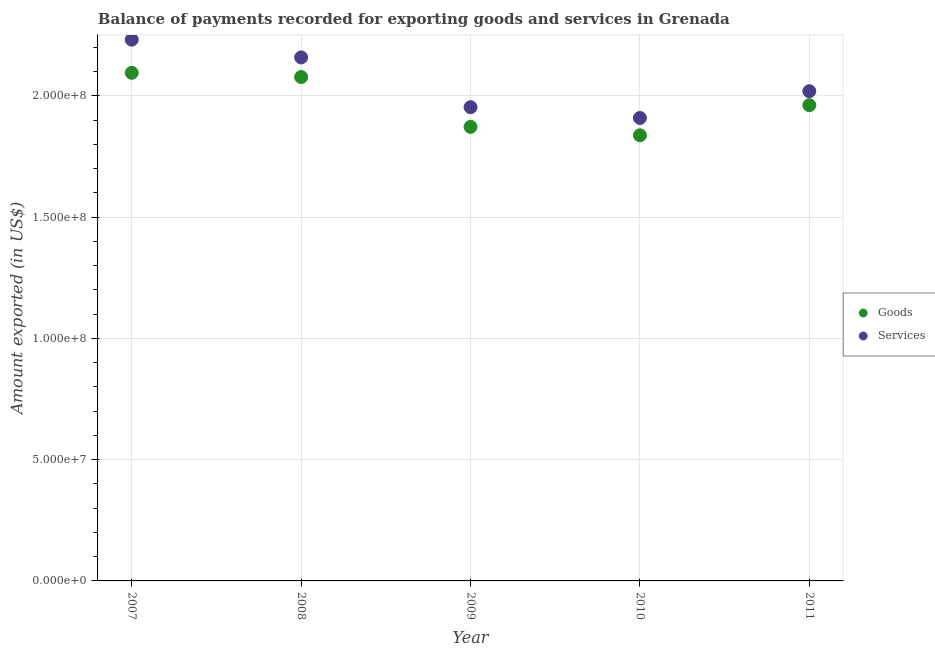What is the amount of goods exported in 2010?
Your response must be concise. 1.84e+08. Across all years, what is the maximum amount of services exported?
Make the answer very short. 2.23e+08. Across all years, what is the minimum amount of goods exported?
Your answer should be compact. 1.84e+08. In which year was the amount of goods exported maximum?
Your answer should be compact. 2007. What is the total amount of services exported in the graph?
Your response must be concise. 1.03e+09. What is the difference between the amount of goods exported in 2007 and that in 2010?
Your answer should be compact. 2.58e+07. What is the difference between the amount of goods exported in 2011 and the amount of services exported in 2008?
Keep it short and to the point. -1.97e+07. What is the average amount of goods exported per year?
Your answer should be very brief. 1.97e+08. In the year 2007, what is the difference between the amount of goods exported and amount of services exported?
Your answer should be very brief. -1.37e+07. What is the ratio of the amount of goods exported in 2008 to that in 2009?
Keep it short and to the point. 1.11. Is the difference between the amount of goods exported in 2009 and 2011 greater than the difference between the amount of services exported in 2009 and 2011?
Give a very brief answer. No. What is the difference between the highest and the second highest amount of goods exported?
Keep it short and to the point. 1.75e+06. What is the difference between the highest and the lowest amount of services exported?
Your response must be concise. 3.23e+07. In how many years, is the amount of goods exported greater than the average amount of goods exported taken over all years?
Offer a very short reply. 2. Does the amount of services exported monotonically increase over the years?
Ensure brevity in your answer.  No. Is the amount of goods exported strictly greater than the amount of services exported over the years?
Offer a very short reply. No. How many dotlines are there?
Your response must be concise. 2. Where does the legend appear in the graph?
Your answer should be very brief. Center right. How are the legend labels stacked?
Give a very brief answer. Vertical. What is the title of the graph?
Ensure brevity in your answer.  Balance of payments recorded for exporting goods and services in Grenada. What is the label or title of the Y-axis?
Provide a succinct answer. Amount exported (in US$). What is the Amount exported (in US$) of Goods in 2007?
Provide a short and direct response. 2.10e+08. What is the Amount exported (in US$) of Services in 2007?
Ensure brevity in your answer.  2.23e+08. What is the Amount exported (in US$) in Goods in 2008?
Give a very brief answer. 2.08e+08. What is the Amount exported (in US$) in Services in 2008?
Offer a very short reply. 2.16e+08. What is the Amount exported (in US$) of Goods in 2009?
Make the answer very short. 1.87e+08. What is the Amount exported (in US$) in Services in 2009?
Offer a very short reply. 1.95e+08. What is the Amount exported (in US$) of Goods in 2010?
Your response must be concise. 1.84e+08. What is the Amount exported (in US$) of Services in 2010?
Your response must be concise. 1.91e+08. What is the Amount exported (in US$) of Goods in 2011?
Provide a short and direct response. 1.96e+08. What is the Amount exported (in US$) of Services in 2011?
Offer a very short reply. 2.02e+08. Across all years, what is the maximum Amount exported (in US$) of Goods?
Offer a terse response. 2.10e+08. Across all years, what is the maximum Amount exported (in US$) in Services?
Ensure brevity in your answer.  2.23e+08. Across all years, what is the minimum Amount exported (in US$) of Goods?
Your answer should be very brief. 1.84e+08. Across all years, what is the minimum Amount exported (in US$) of Services?
Your answer should be very brief. 1.91e+08. What is the total Amount exported (in US$) in Goods in the graph?
Keep it short and to the point. 9.85e+08. What is the total Amount exported (in US$) in Services in the graph?
Offer a very short reply. 1.03e+09. What is the difference between the Amount exported (in US$) in Goods in 2007 and that in 2008?
Provide a short and direct response. 1.75e+06. What is the difference between the Amount exported (in US$) in Services in 2007 and that in 2008?
Offer a terse response. 7.32e+06. What is the difference between the Amount exported (in US$) in Goods in 2007 and that in 2009?
Make the answer very short. 2.23e+07. What is the difference between the Amount exported (in US$) of Services in 2007 and that in 2009?
Your answer should be very brief. 2.78e+07. What is the difference between the Amount exported (in US$) in Goods in 2007 and that in 2010?
Make the answer very short. 2.58e+07. What is the difference between the Amount exported (in US$) in Services in 2007 and that in 2010?
Give a very brief answer. 3.23e+07. What is the difference between the Amount exported (in US$) of Goods in 2007 and that in 2011?
Your answer should be compact. 1.34e+07. What is the difference between the Amount exported (in US$) in Services in 2007 and that in 2011?
Your response must be concise. 2.13e+07. What is the difference between the Amount exported (in US$) in Goods in 2008 and that in 2009?
Your answer should be very brief. 2.06e+07. What is the difference between the Amount exported (in US$) in Services in 2008 and that in 2009?
Your answer should be compact. 2.05e+07. What is the difference between the Amount exported (in US$) in Goods in 2008 and that in 2010?
Offer a very short reply. 2.40e+07. What is the difference between the Amount exported (in US$) in Services in 2008 and that in 2010?
Make the answer very short. 2.50e+07. What is the difference between the Amount exported (in US$) in Goods in 2008 and that in 2011?
Your answer should be compact. 1.16e+07. What is the difference between the Amount exported (in US$) of Services in 2008 and that in 2011?
Offer a terse response. 1.39e+07. What is the difference between the Amount exported (in US$) of Goods in 2009 and that in 2010?
Provide a short and direct response. 3.48e+06. What is the difference between the Amount exported (in US$) in Services in 2009 and that in 2010?
Provide a succinct answer. 4.45e+06. What is the difference between the Amount exported (in US$) in Goods in 2009 and that in 2011?
Give a very brief answer. -8.94e+06. What is the difference between the Amount exported (in US$) of Services in 2009 and that in 2011?
Offer a very short reply. -6.59e+06. What is the difference between the Amount exported (in US$) of Goods in 2010 and that in 2011?
Make the answer very short. -1.24e+07. What is the difference between the Amount exported (in US$) in Services in 2010 and that in 2011?
Provide a short and direct response. -1.10e+07. What is the difference between the Amount exported (in US$) of Goods in 2007 and the Amount exported (in US$) of Services in 2008?
Offer a terse response. -6.34e+06. What is the difference between the Amount exported (in US$) of Goods in 2007 and the Amount exported (in US$) of Services in 2009?
Your response must be concise. 1.42e+07. What is the difference between the Amount exported (in US$) of Goods in 2007 and the Amount exported (in US$) of Services in 2010?
Your answer should be very brief. 1.86e+07. What is the difference between the Amount exported (in US$) in Goods in 2007 and the Amount exported (in US$) in Services in 2011?
Your answer should be compact. 7.59e+06. What is the difference between the Amount exported (in US$) in Goods in 2008 and the Amount exported (in US$) in Services in 2009?
Offer a terse response. 1.24e+07. What is the difference between the Amount exported (in US$) in Goods in 2008 and the Amount exported (in US$) in Services in 2010?
Offer a terse response. 1.69e+07. What is the difference between the Amount exported (in US$) of Goods in 2008 and the Amount exported (in US$) of Services in 2011?
Make the answer very short. 5.85e+06. What is the difference between the Amount exported (in US$) in Goods in 2009 and the Amount exported (in US$) in Services in 2010?
Your answer should be compact. -3.68e+06. What is the difference between the Amount exported (in US$) in Goods in 2009 and the Amount exported (in US$) in Services in 2011?
Offer a very short reply. -1.47e+07. What is the difference between the Amount exported (in US$) in Goods in 2010 and the Amount exported (in US$) in Services in 2011?
Make the answer very short. -1.82e+07. What is the average Amount exported (in US$) of Goods per year?
Your answer should be compact. 1.97e+08. What is the average Amount exported (in US$) of Services per year?
Provide a succinct answer. 2.05e+08. In the year 2007, what is the difference between the Amount exported (in US$) of Goods and Amount exported (in US$) of Services?
Your answer should be compact. -1.37e+07. In the year 2008, what is the difference between the Amount exported (in US$) of Goods and Amount exported (in US$) of Services?
Provide a succinct answer. -8.08e+06. In the year 2009, what is the difference between the Amount exported (in US$) of Goods and Amount exported (in US$) of Services?
Keep it short and to the point. -8.12e+06. In the year 2010, what is the difference between the Amount exported (in US$) in Goods and Amount exported (in US$) in Services?
Your answer should be very brief. -7.15e+06. In the year 2011, what is the difference between the Amount exported (in US$) in Goods and Amount exported (in US$) in Services?
Give a very brief answer. -5.77e+06. What is the ratio of the Amount exported (in US$) in Goods in 2007 to that in 2008?
Your response must be concise. 1.01. What is the ratio of the Amount exported (in US$) in Services in 2007 to that in 2008?
Ensure brevity in your answer.  1.03. What is the ratio of the Amount exported (in US$) of Goods in 2007 to that in 2009?
Your response must be concise. 1.12. What is the ratio of the Amount exported (in US$) in Services in 2007 to that in 2009?
Give a very brief answer. 1.14. What is the ratio of the Amount exported (in US$) of Goods in 2007 to that in 2010?
Ensure brevity in your answer.  1.14. What is the ratio of the Amount exported (in US$) of Services in 2007 to that in 2010?
Your answer should be compact. 1.17. What is the ratio of the Amount exported (in US$) of Goods in 2007 to that in 2011?
Your answer should be very brief. 1.07. What is the ratio of the Amount exported (in US$) in Services in 2007 to that in 2011?
Your answer should be compact. 1.11. What is the ratio of the Amount exported (in US$) of Goods in 2008 to that in 2009?
Make the answer very short. 1.11. What is the ratio of the Amount exported (in US$) of Services in 2008 to that in 2009?
Your answer should be compact. 1.1. What is the ratio of the Amount exported (in US$) in Goods in 2008 to that in 2010?
Make the answer very short. 1.13. What is the ratio of the Amount exported (in US$) in Services in 2008 to that in 2010?
Offer a very short reply. 1.13. What is the ratio of the Amount exported (in US$) of Goods in 2008 to that in 2011?
Provide a succinct answer. 1.06. What is the ratio of the Amount exported (in US$) of Services in 2008 to that in 2011?
Keep it short and to the point. 1.07. What is the ratio of the Amount exported (in US$) in Goods in 2009 to that in 2010?
Your answer should be compact. 1.02. What is the ratio of the Amount exported (in US$) in Services in 2009 to that in 2010?
Provide a succinct answer. 1.02. What is the ratio of the Amount exported (in US$) in Goods in 2009 to that in 2011?
Your answer should be compact. 0.95. What is the ratio of the Amount exported (in US$) of Services in 2009 to that in 2011?
Your answer should be compact. 0.97. What is the ratio of the Amount exported (in US$) of Goods in 2010 to that in 2011?
Give a very brief answer. 0.94. What is the ratio of the Amount exported (in US$) in Services in 2010 to that in 2011?
Your answer should be compact. 0.95. What is the difference between the highest and the second highest Amount exported (in US$) in Goods?
Your answer should be compact. 1.75e+06. What is the difference between the highest and the second highest Amount exported (in US$) of Services?
Keep it short and to the point. 7.32e+06. What is the difference between the highest and the lowest Amount exported (in US$) in Goods?
Offer a very short reply. 2.58e+07. What is the difference between the highest and the lowest Amount exported (in US$) of Services?
Make the answer very short. 3.23e+07. 